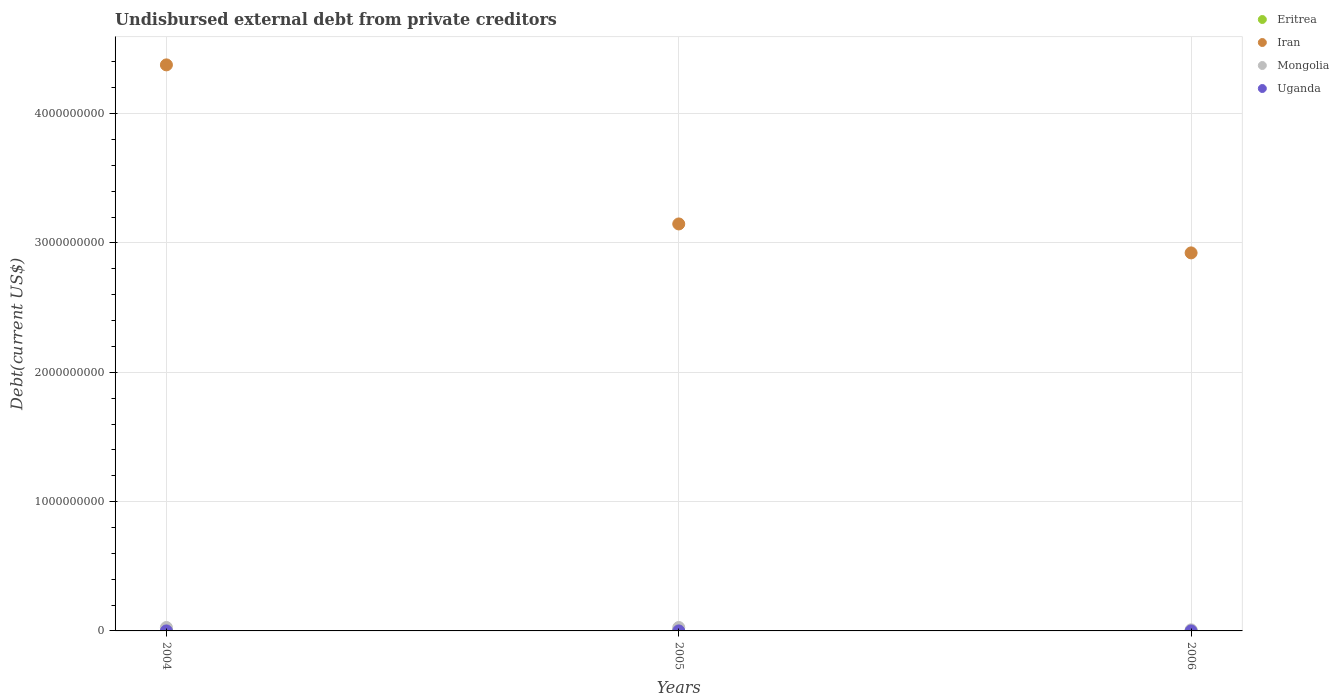Is the number of dotlines equal to the number of legend labels?
Give a very brief answer. Yes. What is the total debt in Eritrea in 2006?
Give a very brief answer. 7.23e+05. Across all years, what is the maximum total debt in Mongolia?
Your answer should be very brief. 2.65e+07. Across all years, what is the minimum total debt in Uganda?
Keep it short and to the point. 2.10e+04. In which year was the total debt in Iran maximum?
Give a very brief answer. 2004. In which year was the total debt in Eritrea minimum?
Offer a very short reply. 2005. What is the total total debt in Uganda in the graph?
Offer a very short reply. 7.00e+04. What is the difference between the total debt in Uganda in 2004 and that in 2006?
Ensure brevity in your answer.  1000. What is the difference between the total debt in Iran in 2006 and the total debt in Uganda in 2004?
Your answer should be compact. 2.92e+09. What is the average total debt in Mongolia per year?
Offer a very short reply. 2.05e+07. In the year 2004, what is the difference between the total debt in Iran and total debt in Mongolia?
Your answer should be very brief. 4.35e+09. What is the ratio of the total debt in Eritrea in 2004 to that in 2005?
Provide a short and direct response. 1.15. Is the difference between the total debt in Iran in 2004 and 2005 greater than the difference between the total debt in Mongolia in 2004 and 2005?
Make the answer very short. Yes. What is the difference between the highest and the lowest total debt in Iran?
Your response must be concise. 1.45e+09. Does the total debt in Iran monotonically increase over the years?
Make the answer very short. No. Is the total debt in Iran strictly greater than the total debt in Uganda over the years?
Give a very brief answer. Yes. What is the difference between two consecutive major ticks on the Y-axis?
Provide a succinct answer. 1.00e+09. Are the values on the major ticks of Y-axis written in scientific E-notation?
Provide a short and direct response. No. Does the graph contain any zero values?
Ensure brevity in your answer.  No. Where does the legend appear in the graph?
Offer a very short reply. Top right. How many legend labels are there?
Provide a succinct answer. 4. What is the title of the graph?
Offer a terse response. Undisbursed external debt from private creditors. What is the label or title of the X-axis?
Your answer should be very brief. Years. What is the label or title of the Y-axis?
Ensure brevity in your answer.  Debt(current US$). What is the Debt(current US$) in Eritrea in 2004?
Make the answer very short. 7.48e+05. What is the Debt(current US$) in Iran in 2004?
Offer a very short reply. 4.38e+09. What is the Debt(current US$) in Mongolia in 2004?
Give a very brief answer. 2.65e+07. What is the Debt(current US$) in Uganda in 2004?
Offer a terse response. 2.50e+04. What is the Debt(current US$) in Eritrea in 2005?
Make the answer very short. 6.48e+05. What is the Debt(current US$) in Iran in 2005?
Keep it short and to the point. 3.15e+09. What is the Debt(current US$) in Mongolia in 2005?
Keep it short and to the point. 2.65e+07. What is the Debt(current US$) in Uganda in 2005?
Your response must be concise. 2.10e+04. What is the Debt(current US$) of Eritrea in 2006?
Provide a short and direct response. 7.23e+05. What is the Debt(current US$) of Iran in 2006?
Your answer should be compact. 2.92e+09. What is the Debt(current US$) in Mongolia in 2006?
Your answer should be very brief. 8.40e+06. What is the Debt(current US$) of Uganda in 2006?
Offer a very short reply. 2.40e+04. Across all years, what is the maximum Debt(current US$) of Eritrea?
Your response must be concise. 7.48e+05. Across all years, what is the maximum Debt(current US$) in Iran?
Offer a very short reply. 4.38e+09. Across all years, what is the maximum Debt(current US$) of Mongolia?
Ensure brevity in your answer.  2.65e+07. Across all years, what is the maximum Debt(current US$) in Uganda?
Your response must be concise. 2.50e+04. Across all years, what is the minimum Debt(current US$) in Eritrea?
Offer a very short reply. 6.48e+05. Across all years, what is the minimum Debt(current US$) in Iran?
Keep it short and to the point. 2.92e+09. Across all years, what is the minimum Debt(current US$) of Mongolia?
Ensure brevity in your answer.  8.40e+06. Across all years, what is the minimum Debt(current US$) in Uganda?
Give a very brief answer. 2.10e+04. What is the total Debt(current US$) of Eritrea in the graph?
Your answer should be compact. 2.12e+06. What is the total Debt(current US$) in Iran in the graph?
Keep it short and to the point. 1.04e+1. What is the total Debt(current US$) of Mongolia in the graph?
Provide a succinct answer. 6.14e+07. What is the total Debt(current US$) in Uganda in the graph?
Your answer should be compact. 7.00e+04. What is the difference between the Debt(current US$) in Eritrea in 2004 and that in 2005?
Keep it short and to the point. 1.00e+05. What is the difference between the Debt(current US$) in Iran in 2004 and that in 2005?
Make the answer very short. 1.23e+09. What is the difference between the Debt(current US$) of Uganda in 2004 and that in 2005?
Offer a terse response. 4000. What is the difference between the Debt(current US$) in Eritrea in 2004 and that in 2006?
Offer a very short reply. 2.50e+04. What is the difference between the Debt(current US$) in Iran in 2004 and that in 2006?
Your response must be concise. 1.45e+09. What is the difference between the Debt(current US$) of Mongolia in 2004 and that in 2006?
Your answer should be compact. 1.81e+07. What is the difference between the Debt(current US$) in Eritrea in 2005 and that in 2006?
Your answer should be very brief. -7.50e+04. What is the difference between the Debt(current US$) of Iran in 2005 and that in 2006?
Offer a very short reply. 2.24e+08. What is the difference between the Debt(current US$) of Mongolia in 2005 and that in 2006?
Provide a short and direct response. 1.81e+07. What is the difference between the Debt(current US$) of Uganda in 2005 and that in 2006?
Your answer should be very brief. -3000. What is the difference between the Debt(current US$) in Eritrea in 2004 and the Debt(current US$) in Iran in 2005?
Offer a very short reply. -3.15e+09. What is the difference between the Debt(current US$) of Eritrea in 2004 and the Debt(current US$) of Mongolia in 2005?
Your answer should be compact. -2.58e+07. What is the difference between the Debt(current US$) of Eritrea in 2004 and the Debt(current US$) of Uganda in 2005?
Keep it short and to the point. 7.27e+05. What is the difference between the Debt(current US$) in Iran in 2004 and the Debt(current US$) in Mongolia in 2005?
Your answer should be very brief. 4.35e+09. What is the difference between the Debt(current US$) in Iran in 2004 and the Debt(current US$) in Uganda in 2005?
Provide a succinct answer. 4.38e+09. What is the difference between the Debt(current US$) in Mongolia in 2004 and the Debt(current US$) in Uganda in 2005?
Provide a succinct answer. 2.65e+07. What is the difference between the Debt(current US$) of Eritrea in 2004 and the Debt(current US$) of Iran in 2006?
Make the answer very short. -2.92e+09. What is the difference between the Debt(current US$) in Eritrea in 2004 and the Debt(current US$) in Mongolia in 2006?
Keep it short and to the point. -7.65e+06. What is the difference between the Debt(current US$) of Eritrea in 2004 and the Debt(current US$) of Uganda in 2006?
Your response must be concise. 7.24e+05. What is the difference between the Debt(current US$) of Iran in 2004 and the Debt(current US$) of Mongolia in 2006?
Give a very brief answer. 4.37e+09. What is the difference between the Debt(current US$) of Iran in 2004 and the Debt(current US$) of Uganda in 2006?
Ensure brevity in your answer.  4.38e+09. What is the difference between the Debt(current US$) of Mongolia in 2004 and the Debt(current US$) of Uganda in 2006?
Provide a succinct answer. 2.65e+07. What is the difference between the Debt(current US$) of Eritrea in 2005 and the Debt(current US$) of Iran in 2006?
Make the answer very short. -2.92e+09. What is the difference between the Debt(current US$) of Eritrea in 2005 and the Debt(current US$) of Mongolia in 2006?
Your response must be concise. -7.75e+06. What is the difference between the Debt(current US$) of Eritrea in 2005 and the Debt(current US$) of Uganda in 2006?
Offer a very short reply. 6.24e+05. What is the difference between the Debt(current US$) of Iran in 2005 and the Debt(current US$) of Mongolia in 2006?
Offer a terse response. 3.14e+09. What is the difference between the Debt(current US$) of Iran in 2005 and the Debt(current US$) of Uganda in 2006?
Provide a succinct answer. 3.15e+09. What is the difference between the Debt(current US$) of Mongolia in 2005 and the Debt(current US$) of Uganda in 2006?
Your answer should be compact. 2.65e+07. What is the average Debt(current US$) in Eritrea per year?
Offer a very short reply. 7.06e+05. What is the average Debt(current US$) of Iran per year?
Keep it short and to the point. 3.48e+09. What is the average Debt(current US$) in Mongolia per year?
Offer a terse response. 2.05e+07. What is the average Debt(current US$) of Uganda per year?
Ensure brevity in your answer.  2.33e+04. In the year 2004, what is the difference between the Debt(current US$) in Eritrea and Debt(current US$) in Iran?
Ensure brevity in your answer.  -4.38e+09. In the year 2004, what is the difference between the Debt(current US$) of Eritrea and Debt(current US$) of Mongolia?
Keep it short and to the point. -2.58e+07. In the year 2004, what is the difference between the Debt(current US$) of Eritrea and Debt(current US$) of Uganda?
Your response must be concise. 7.23e+05. In the year 2004, what is the difference between the Debt(current US$) in Iran and Debt(current US$) in Mongolia?
Your answer should be compact. 4.35e+09. In the year 2004, what is the difference between the Debt(current US$) in Iran and Debt(current US$) in Uganda?
Give a very brief answer. 4.38e+09. In the year 2004, what is the difference between the Debt(current US$) of Mongolia and Debt(current US$) of Uganda?
Offer a terse response. 2.65e+07. In the year 2005, what is the difference between the Debt(current US$) of Eritrea and Debt(current US$) of Iran?
Your answer should be very brief. -3.15e+09. In the year 2005, what is the difference between the Debt(current US$) in Eritrea and Debt(current US$) in Mongolia?
Give a very brief answer. -2.59e+07. In the year 2005, what is the difference between the Debt(current US$) of Eritrea and Debt(current US$) of Uganda?
Offer a very short reply. 6.27e+05. In the year 2005, what is the difference between the Debt(current US$) in Iran and Debt(current US$) in Mongolia?
Ensure brevity in your answer.  3.12e+09. In the year 2005, what is the difference between the Debt(current US$) of Iran and Debt(current US$) of Uganda?
Keep it short and to the point. 3.15e+09. In the year 2005, what is the difference between the Debt(current US$) in Mongolia and Debt(current US$) in Uganda?
Your response must be concise. 2.65e+07. In the year 2006, what is the difference between the Debt(current US$) in Eritrea and Debt(current US$) in Iran?
Your answer should be very brief. -2.92e+09. In the year 2006, what is the difference between the Debt(current US$) in Eritrea and Debt(current US$) in Mongolia?
Keep it short and to the point. -7.68e+06. In the year 2006, what is the difference between the Debt(current US$) of Eritrea and Debt(current US$) of Uganda?
Keep it short and to the point. 6.99e+05. In the year 2006, what is the difference between the Debt(current US$) of Iran and Debt(current US$) of Mongolia?
Provide a short and direct response. 2.91e+09. In the year 2006, what is the difference between the Debt(current US$) in Iran and Debt(current US$) in Uganda?
Make the answer very short. 2.92e+09. In the year 2006, what is the difference between the Debt(current US$) of Mongolia and Debt(current US$) of Uganda?
Offer a terse response. 8.38e+06. What is the ratio of the Debt(current US$) of Eritrea in 2004 to that in 2005?
Ensure brevity in your answer.  1.15. What is the ratio of the Debt(current US$) in Iran in 2004 to that in 2005?
Provide a succinct answer. 1.39. What is the ratio of the Debt(current US$) in Mongolia in 2004 to that in 2005?
Give a very brief answer. 1. What is the ratio of the Debt(current US$) in Uganda in 2004 to that in 2005?
Your response must be concise. 1.19. What is the ratio of the Debt(current US$) in Eritrea in 2004 to that in 2006?
Ensure brevity in your answer.  1.03. What is the ratio of the Debt(current US$) of Iran in 2004 to that in 2006?
Keep it short and to the point. 1.5. What is the ratio of the Debt(current US$) in Mongolia in 2004 to that in 2006?
Give a very brief answer. 3.15. What is the ratio of the Debt(current US$) in Uganda in 2004 to that in 2006?
Keep it short and to the point. 1.04. What is the ratio of the Debt(current US$) in Eritrea in 2005 to that in 2006?
Ensure brevity in your answer.  0.9. What is the ratio of the Debt(current US$) of Iran in 2005 to that in 2006?
Offer a very short reply. 1.08. What is the ratio of the Debt(current US$) of Mongolia in 2005 to that in 2006?
Ensure brevity in your answer.  3.15. What is the ratio of the Debt(current US$) in Uganda in 2005 to that in 2006?
Give a very brief answer. 0.88. What is the difference between the highest and the second highest Debt(current US$) of Eritrea?
Make the answer very short. 2.50e+04. What is the difference between the highest and the second highest Debt(current US$) of Iran?
Make the answer very short. 1.23e+09. What is the difference between the highest and the second highest Debt(current US$) of Mongolia?
Provide a short and direct response. 0. What is the difference between the highest and the second highest Debt(current US$) in Uganda?
Your response must be concise. 1000. What is the difference between the highest and the lowest Debt(current US$) in Iran?
Keep it short and to the point. 1.45e+09. What is the difference between the highest and the lowest Debt(current US$) of Mongolia?
Give a very brief answer. 1.81e+07. What is the difference between the highest and the lowest Debt(current US$) of Uganda?
Keep it short and to the point. 4000. 